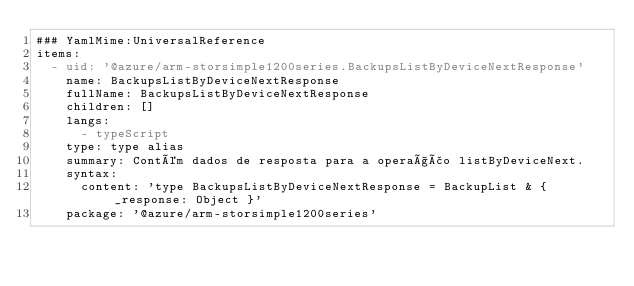<code> <loc_0><loc_0><loc_500><loc_500><_YAML_>### YamlMime:UniversalReference
items:
  - uid: '@azure/arm-storsimple1200series.BackupsListByDeviceNextResponse'
    name: BackupsListByDeviceNextResponse
    fullName: BackupsListByDeviceNextResponse
    children: []
    langs:
      - typeScript
    type: type alias
    summary: Contém dados de resposta para a operação listByDeviceNext.
    syntax:
      content: 'type BackupsListByDeviceNextResponse = BackupList & { _response: Object }'
    package: '@azure/arm-storsimple1200series'</code> 